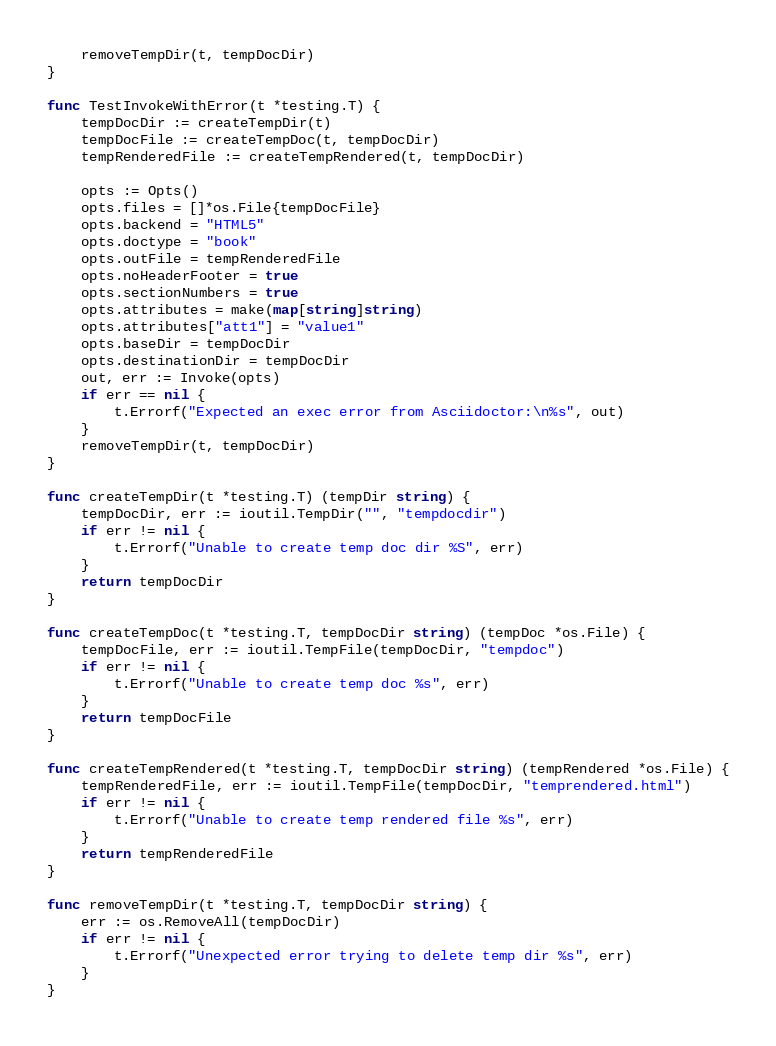Convert code to text. <code><loc_0><loc_0><loc_500><loc_500><_Go_>    removeTempDir(t, tempDocDir)
}

func TestInvokeWithError(t *testing.T) {
    tempDocDir := createTempDir(t)
    tempDocFile := createTempDoc(t, tempDocDir)
    tempRenderedFile := createTempRendered(t, tempDocDir)
    
    opts := Opts()
    opts.files = []*os.File{tempDocFile}
    opts.backend = "HTML5"
    opts.doctype = "book"
    opts.outFile = tempRenderedFile
    opts.noHeaderFooter = true
    opts.sectionNumbers = true
    opts.attributes = make(map[string]string)
    opts.attributes["att1"] = "value1"
    opts.baseDir = tempDocDir
    opts.destinationDir = tempDocDir
    out, err := Invoke(opts)
    if err == nil {
        t.Errorf("Expected an exec error from Asciidoctor:\n%s", out)
    }
    removeTempDir(t, tempDocDir)
}

func createTempDir(t *testing.T) (tempDir string) {
    tempDocDir, err := ioutil.TempDir("", "tempdocdir")
    if err != nil {
        t.Errorf("Unable to create temp doc dir %S", err)
    }
    return tempDocDir
}

func createTempDoc(t *testing.T, tempDocDir string) (tempDoc *os.File) {
    tempDocFile, err := ioutil.TempFile(tempDocDir, "tempdoc")
    if err != nil {
        t.Errorf("Unable to create temp doc %s", err)
    }
    return tempDocFile
}

func createTempRendered(t *testing.T, tempDocDir string) (tempRendered *os.File) {
    tempRenderedFile, err := ioutil.TempFile(tempDocDir, "temprendered.html")
    if err != nil {
        t.Errorf("Unable to create temp rendered file %s", err)
    }
    return tempRenderedFile
}

func removeTempDir(t *testing.T, tempDocDir string) {
    err := os.RemoveAll(tempDocDir)
    if err != nil {
        t.Errorf("Unexpected error trying to delete temp dir %s", err)
    }
}
</code> 